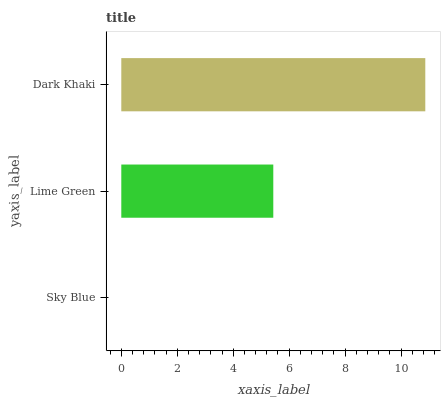Is Sky Blue the minimum?
Answer yes or no. Yes. Is Dark Khaki the maximum?
Answer yes or no. Yes. Is Lime Green the minimum?
Answer yes or no. No. Is Lime Green the maximum?
Answer yes or no. No. Is Lime Green greater than Sky Blue?
Answer yes or no. Yes. Is Sky Blue less than Lime Green?
Answer yes or no. Yes. Is Sky Blue greater than Lime Green?
Answer yes or no. No. Is Lime Green less than Sky Blue?
Answer yes or no. No. Is Lime Green the high median?
Answer yes or no. Yes. Is Lime Green the low median?
Answer yes or no. Yes. Is Dark Khaki the high median?
Answer yes or no. No. Is Sky Blue the low median?
Answer yes or no. No. 